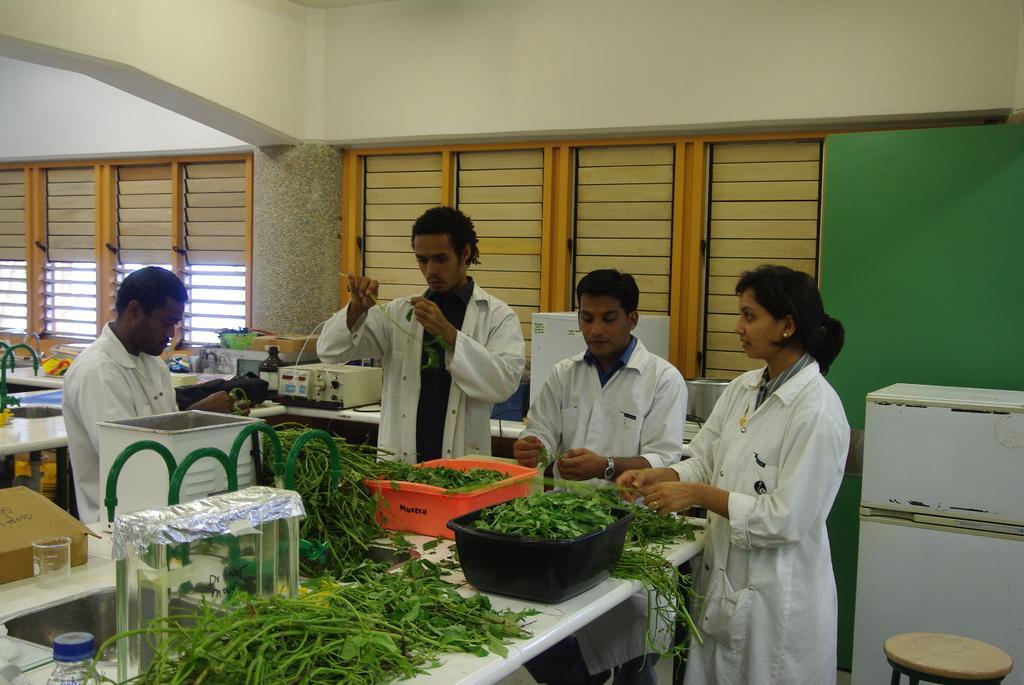In one or two sentences, can you explain what this image depicts? This picture is clicked inside. In the foreground we can see a stool and a white color platform on which we can see the green leaves and the containers containing the green leaves are placed on the top of the table and we can see a bottle, beaker and many other objects are placed on the top of the tables and there are some objects placed on the ground. In the background we can see the wall, windows and the window blinds and we can see the group of persons standing, holding some objects and seems to be working. 